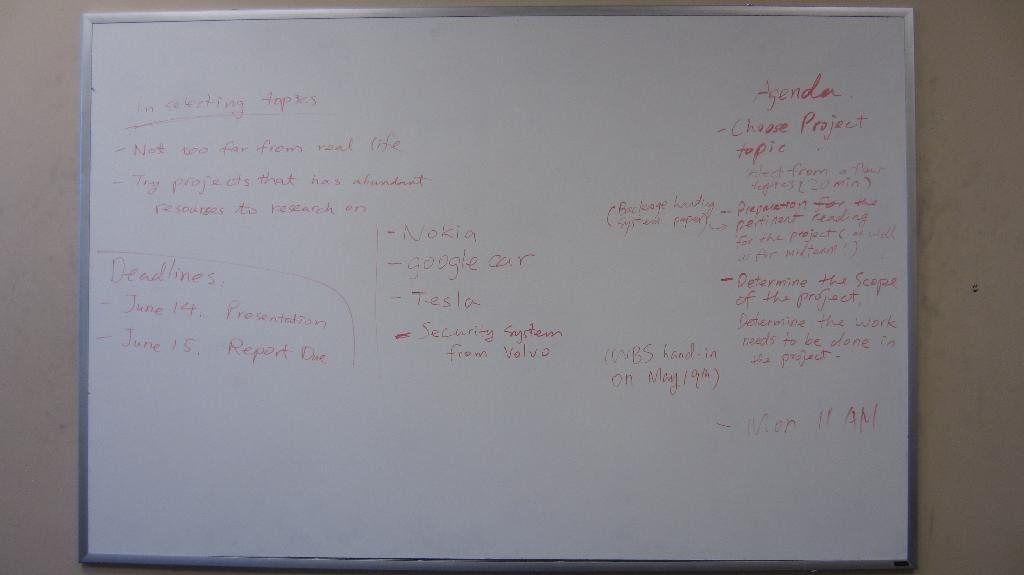<image>
Offer a succinct explanation of the picture presented. A white dry erase board with the word "Agenda" written in red dry-erase ink 